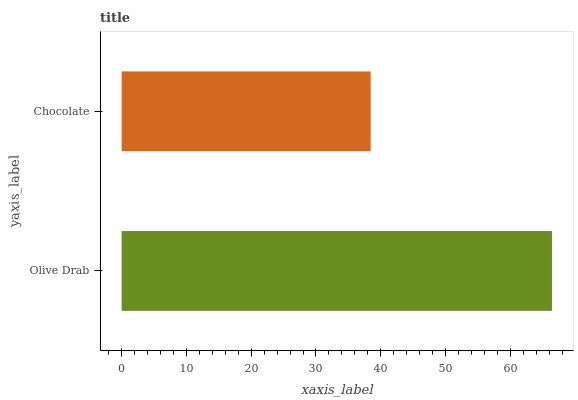Is Chocolate the minimum?
Answer yes or no. Yes. Is Olive Drab the maximum?
Answer yes or no. Yes. Is Chocolate the maximum?
Answer yes or no. No. Is Olive Drab greater than Chocolate?
Answer yes or no. Yes. Is Chocolate less than Olive Drab?
Answer yes or no. Yes. Is Chocolate greater than Olive Drab?
Answer yes or no. No. Is Olive Drab less than Chocolate?
Answer yes or no. No. Is Olive Drab the high median?
Answer yes or no. Yes. Is Chocolate the low median?
Answer yes or no. Yes. Is Chocolate the high median?
Answer yes or no. No. Is Olive Drab the low median?
Answer yes or no. No. 